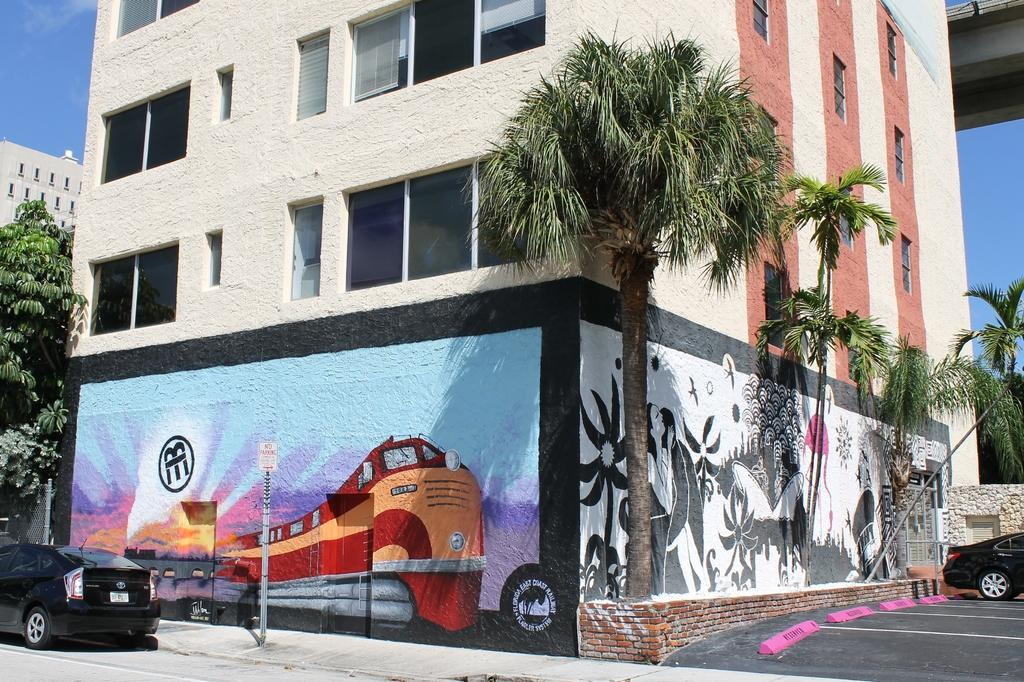What type of structures can be seen in the image? There are buildings in the image. What else can be seen on the ground in the image? Vehicles are present on the road in the image. What natural elements are visible in the image? Trees are visible in the image. What additional objects can be seen in the image? Poles are present in the image. Are there any decorative elements in the image? Yes, there is a painting on the wall of a building in the image. What is visible in the background of the image? The sky is visible in the background of the image. What type of mint is growing on the poles in the image? There is no mint growing on the poles in the image; only trees and buildings are visible. Are there any slaves depicted in the painting on the wall of the building in the image? There is no information about the content of the painting in the image, but there is no indication of any slaves being depicted. 